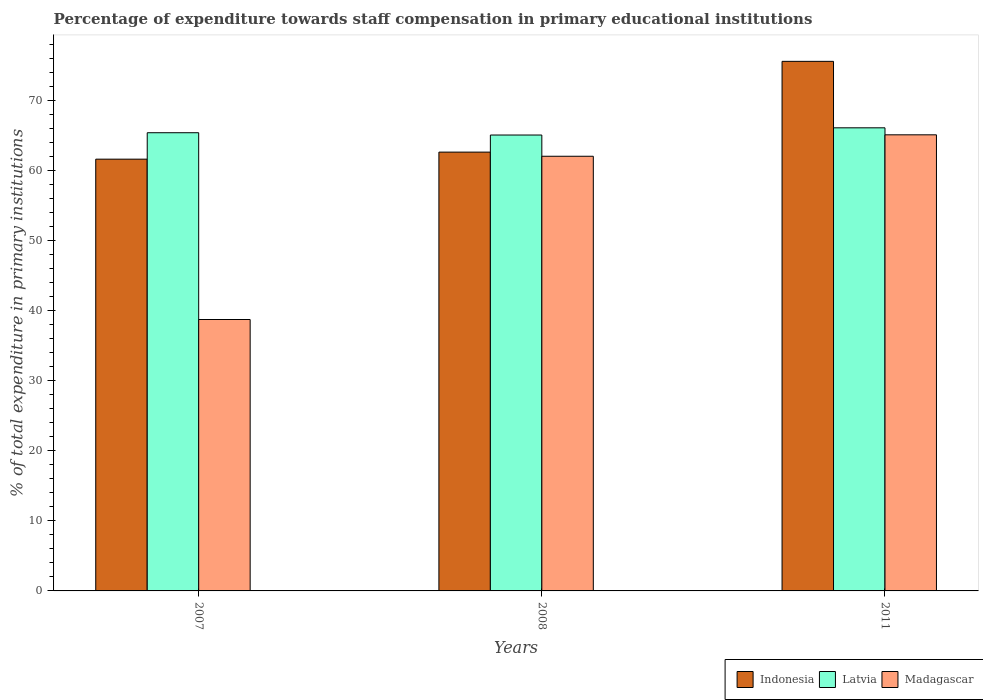Are the number of bars per tick equal to the number of legend labels?
Your answer should be very brief. Yes. How many bars are there on the 2nd tick from the left?
Give a very brief answer. 3. In how many cases, is the number of bars for a given year not equal to the number of legend labels?
Make the answer very short. 0. What is the percentage of expenditure towards staff compensation in Madagascar in 2008?
Make the answer very short. 62.02. Across all years, what is the maximum percentage of expenditure towards staff compensation in Indonesia?
Give a very brief answer. 75.56. Across all years, what is the minimum percentage of expenditure towards staff compensation in Madagascar?
Give a very brief answer. 38.72. In which year was the percentage of expenditure towards staff compensation in Madagascar minimum?
Provide a short and direct response. 2007. What is the total percentage of expenditure towards staff compensation in Madagascar in the graph?
Give a very brief answer. 165.81. What is the difference between the percentage of expenditure towards staff compensation in Latvia in 2008 and that in 2011?
Offer a terse response. -1.03. What is the difference between the percentage of expenditure towards staff compensation in Indonesia in 2011 and the percentage of expenditure towards staff compensation in Madagascar in 2008?
Provide a short and direct response. 13.54. What is the average percentage of expenditure towards staff compensation in Indonesia per year?
Provide a succinct answer. 66.59. In the year 2011, what is the difference between the percentage of expenditure towards staff compensation in Latvia and percentage of expenditure towards staff compensation in Indonesia?
Give a very brief answer. -9.48. What is the ratio of the percentage of expenditure towards staff compensation in Indonesia in 2007 to that in 2011?
Your response must be concise. 0.82. Is the difference between the percentage of expenditure towards staff compensation in Latvia in 2007 and 2011 greater than the difference between the percentage of expenditure towards staff compensation in Indonesia in 2007 and 2011?
Provide a short and direct response. Yes. What is the difference between the highest and the second highest percentage of expenditure towards staff compensation in Madagascar?
Your response must be concise. 3.06. What is the difference between the highest and the lowest percentage of expenditure towards staff compensation in Latvia?
Provide a short and direct response. 1.03. In how many years, is the percentage of expenditure towards staff compensation in Latvia greater than the average percentage of expenditure towards staff compensation in Latvia taken over all years?
Ensure brevity in your answer.  1. Is the sum of the percentage of expenditure towards staff compensation in Madagascar in 2007 and 2008 greater than the maximum percentage of expenditure towards staff compensation in Latvia across all years?
Provide a succinct answer. Yes. What does the 1st bar from the right in 2008 represents?
Give a very brief answer. Madagascar. Is it the case that in every year, the sum of the percentage of expenditure towards staff compensation in Madagascar and percentage of expenditure towards staff compensation in Latvia is greater than the percentage of expenditure towards staff compensation in Indonesia?
Your answer should be very brief. Yes. How many bars are there?
Provide a short and direct response. 9. Are all the bars in the graph horizontal?
Make the answer very short. No. How many years are there in the graph?
Provide a short and direct response. 3. What is the difference between two consecutive major ticks on the Y-axis?
Offer a terse response. 10. Does the graph contain any zero values?
Your response must be concise. No. How are the legend labels stacked?
Offer a terse response. Horizontal. What is the title of the graph?
Give a very brief answer. Percentage of expenditure towards staff compensation in primary educational institutions. Does "India" appear as one of the legend labels in the graph?
Provide a short and direct response. No. What is the label or title of the Y-axis?
Offer a very short reply. % of total expenditure in primary institutions. What is the % of total expenditure in primary institutions of Indonesia in 2007?
Your answer should be very brief. 61.6. What is the % of total expenditure in primary institutions in Latvia in 2007?
Offer a terse response. 65.37. What is the % of total expenditure in primary institutions in Madagascar in 2007?
Provide a short and direct response. 38.72. What is the % of total expenditure in primary institutions of Indonesia in 2008?
Your answer should be very brief. 62.61. What is the % of total expenditure in primary institutions of Latvia in 2008?
Make the answer very short. 65.05. What is the % of total expenditure in primary institutions in Madagascar in 2008?
Your answer should be very brief. 62.02. What is the % of total expenditure in primary institutions in Indonesia in 2011?
Offer a very short reply. 75.56. What is the % of total expenditure in primary institutions of Latvia in 2011?
Offer a very short reply. 66.07. What is the % of total expenditure in primary institutions in Madagascar in 2011?
Your response must be concise. 65.07. Across all years, what is the maximum % of total expenditure in primary institutions in Indonesia?
Your answer should be very brief. 75.56. Across all years, what is the maximum % of total expenditure in primary institutions of Latvia?
Offer a very short reply. 66.07. Across all years, what is the maximum % of total expenditure in primary institutions in Madagascar?
Keep it short and to the point. 65.07. Across all years, what is the minimum % of total expenditure in primary institutions of Indonesia?
Offer a terse response. 61.6. Across all years, what is the minimum % of total expenditure in primary institutions in Latvia?
Your answer should be very brief. 65.05. Across all years, what is the minimum % of total expenditure in primary institutions of Madagascar?
Provide a succinct answer. 38.72. What is the total % of total expenditure in primary institutions in Indonesia in the graph?
Offer a very short reply. 199.77. What is the total % of total expenditure in primary institutions in Latvia in the graph?
Offer a very short reply. 196.49. What is the total % of total expenditure in primary institutions of Madagascar in the graph?
Your response must be concise. 165.81. What is the difference between the % of total expenditure in primary institutions in Indonesia in 2007 and that in 2008?
Make the answer very short. -1.01. What is the difference between the % of total expenditure in primary institutions of Latvia in 2007 and that in 2008?
Offer a terse response. 0.33. What is the difference between the % of total expenditure in primary institutions in Madagascar in 2007 and that in 2008?
Your response must be concise. -23.29. What is the difference between the % of total expenditure in primary institutions in Indonesia in 2007 and that in 2011?
Ensure brevity in your answer.  -13.95. What is the difference between the % of total expenditure in primary institutions in Latvia in 2007 and that in 2011?
Keep it short and to the point. -0.7. What is the difference between the % of total expenditure in primary institutions in Madagascar in 2007 and that in 2011?
Give a very brief answer. -26.35. What is the difference between the % of total expenditure in primary institutions in Indonesia in 2008 and that in 2011?
Your answer should be very brief. -12.95. What is the difference between the % of total expenditure in primary institutions in Latvia in 2008 and that in 2011?
Keep it short and to the point. -1.03. What is the difference between the % of total expenditure in primary institutions of Madagascar in 2008 and that in 2011?
Provide a succinct answer. -3.06. What is the difference between the % of total expenditure in primary institutions of Indonesia in 2007 and the % of total expenditure in primary institutions of Latvia in 2008?
Provide a succinct answer. -3.44. What is the difference between the % of total expenditure in primary institutions in Indonesia in 2007 and the % of total expenditure in primary institutions in Madagascar in 2008?
Your answer should be compact. -0.41. What is the difference between the % of total expenditure in primary institutions in Latvia in 2007 and the % of total expenditure in primary institutions in Madagascar in 2008?
Give a very brief answer. 3.36. What is the difference between the % of total expenditure in primary institutions of Indonesia in 2007 and the % of total expenditure in primary institutions of Latvia in 2011?
Your response must be concise. -4.47. What is the difference between the % of total expenditure in primary institutions in Indonesia in 2007 and the % of total expenditure in primary institutions in Madagascar in 2011?
Your response must be concise. -3.47. What is the difference between the % of total expenditure in primary institutions of Latvia in 2007 and the % of total expenditure in primary institutions of Madagascar in 2011?
Ensure brevity in your answer.  0.3. What is the difference between the % of total expenditure in primary institutions in Indonesia in 2008 and the % of total expenditure in primary institutions in Latvia in 2011?
Make the answer very short. -3.47. What is the difference between the % of total expenditure in primary institutions in Indonesia in 2008 and the % of total expenditure in primary institutions in Madagascar in 2011?
Your answer should be very brief. -2.47. What is the difference between the % of total expenditure in primary institutions of Latvia in 2008 and the % of total expenditure in primary institutions of Madagascar in 2011?
Your response must be concise. -0.03. What is the average % of total expenditure in primary institutions of Indonesia per year?
Make the answer very short. 66.59. What is the average % of total expenditure in primary institutions in Latvia per year?
Your answer should be compact. 65.5. What is the average % of total expenditure in primary institutions in Madagascar per year?
Offer a terse response. 55.27. In the year 2007, what is the difference between the % of total expenditure in primary institutions of Indonesia and % of total expenditure in primary institutions of Latvia?
Ensure brevity in your answer.  -3.77. In the year 2007, what is the difference between the % of total expenditure in primary institutions of Indonesia and % of total expenditure in primary institutions of Madagascar?
Your answer should be very brief. 22.88. In the year 2007, what is the difference between the % of total expenditure in primary institutions of Latvia and % of total expenditure in primary institutions of Madagascar?
Give a very brief answer. 26.65. In the year 2008, what is the difference between the % of total expenditure in primary institutions of Indonesia and % of total expenditure in primary institutions of Latvia?
Ensure brevity in your answer.  -2.44. In the year 2008, what is the difference between the % of total expenditure in primary institutions in Indonesia and % of total expenditure in primary institutions in Madagascar?
Offer a very short reply. 0.59. In the year 2008, what is the difference between the % of total expenditure in primary institutions of Latvia and % of total expenditure in primary institutions of Madagascar?
Provide a short and direct response. 3.03. In the year 2011, what is the difference between the % of total expenditure in primary institutions in Indonesia and % of total expenditure in primary institutions in Latvia?
Make the answer very short. 9.48. In the year 2011, what is the difference between the % of total expenditure in primary institutions of Indonesia and % of total expenditure in primary institutions of Madagascar?
Offer a very short reply. 10.48. What is the ratio of the % of total expenditure in primary institutions in Indonesia in 2007 to that in 2008?
Give a very brief answer. 0.98. What is the ratio of the % of total expenditure in primary institutions in Madagascar in 2007 to that in 2008?
Your response must be concise. 0.62. What is the ratio of the % of total expenditure in primary institutions in Indonesia in 2007 to that in 2011?
Ensure brevity in your answer.  0.82. What is the ratio of the % of total expenditure in primary institutions in Madagascar in 2007 to that in 2011?
Provide a short and direct response. 0.6. What is the ratio of the % of total expenditure in primary institutions of Indonesia in 2008 to that in 2011?
Offer a terse response. 0.83. What is the ratio of the % of total expenditure in primary institutions of Latvia in 2008 to that in 2011?
Give a very brief answer. 0.98. What is the ratio of the % of total expenditure in primary institutions of Madagascar in 2008 to that in 2011?
Your answer should be compact. 0.95. What is the difference between the highest and the second highest % of total expenditure in primary institutions in Indonesia?
Your answer should be very brief. 12.95. What is the difference between the highest and the second highest % of total expenditure in primary institutions of Latvia?
Keep it short and to the point. 0.7. What is the difference between the highest and the second highest % of total expenditure in primary institutions in Madagascar?
Your response must be concise. 3.06. What is the difference between the highest and the lowest % of total expenditure in primary institutions of Indonesia?
Give a very brief answer. 13.95. What is the difference between the highest and the lowest % of total expenditure in primary institutions in Latvia?
Offer a terse response. 1.03. What is the difference between the highest and the lowest % of total expenditure in primary institutions of Madagascar?
Your answer should be compact. 26.35. 